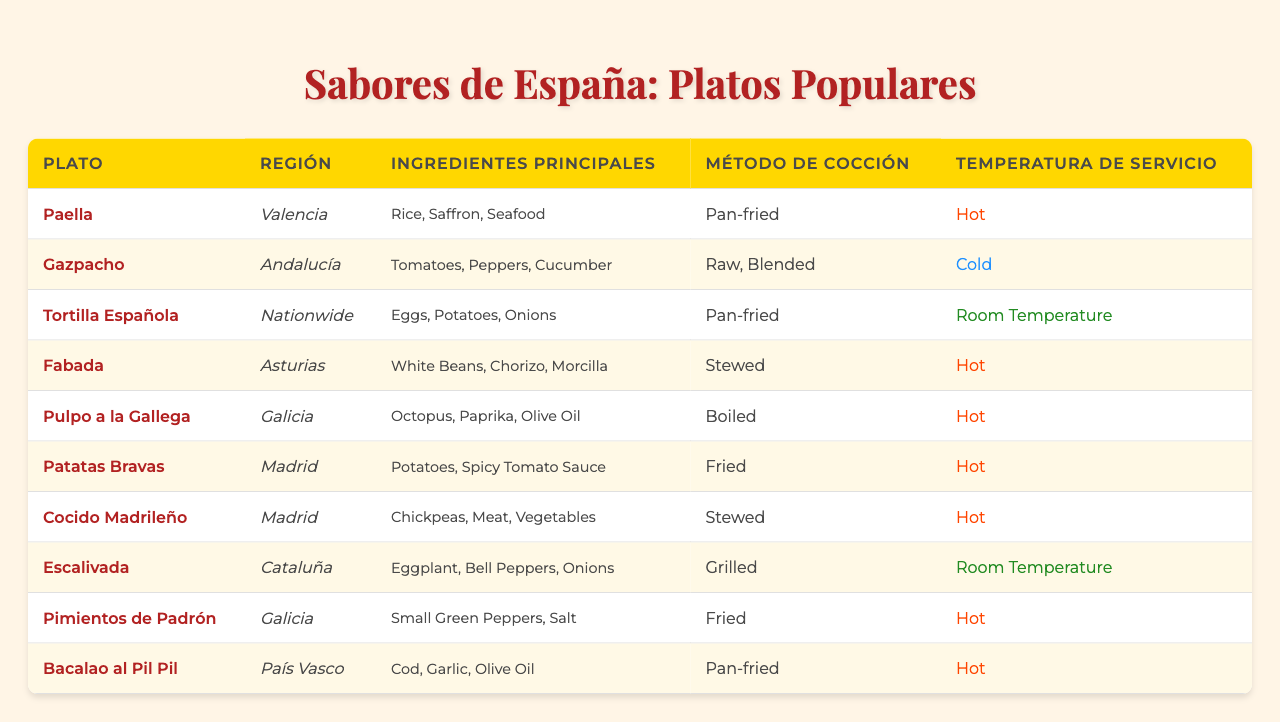What is the origin of Tortilla Española? The table lists Tortilla Española under the "Plato" column and indicates "Nationwide" in the "Región" column.
Answer: Nationwide Which dish is served cold? The table shows that Gazpacho is the only dish listed with "Cold" in the "Temperatura de Servicio" column.
Answer: Gazpacho How many dishes are from the Madrid region? By counting the occurrences of "Madrid" in the "Región" column, we find it appears twice, corresponding to Cocido Madrileño and Patatas Bravas.
Answer: 2 What is the main ingredient of Paella? The "Ingredientes Principales" column shows that the main ingredients used in Paella are Rice, Saffron, and Seafood.
Answer: Rice, Saffron, Seafood Are any dishes served at room temperature? The table indicates that both Tortilla Española and Escalivada are marked with "Room Temperature" in the "Temperatura de Servicio" column.
Answer: Yes What is the cooking method for Bacalao al Pil Pil? The "Método de Cocción" column shows that Bacalao al Pil Pil is prepared by "Pan-fried."
Answer: Pan-fried How many dishes contain potatoes as an ingredient? Checking the "Ingredientes Principales" column, we see that both Tortilla Española and Patatas Bravas contain potatoes, totalling two dishes.
Answer: 2 Which dish has the most diverse main ingredients? By examining the "Ingredientes Principales" column, Fabada has three distinct main ingredients (White Beans, Chorizo, Morcilla), making it one of the most diverse.
Answer: Fabada What temperature is Patatas Bravas served at? The "Temperatura de Servicio" column indicates that Patatas Bravas is served "Hot."
Answer: Hot Is there any dish cooked by boiling? The cooking method for Fabada shows it is "Stewed," and there are no dishes indicated as "Boiled" in the table.
Answer: No 